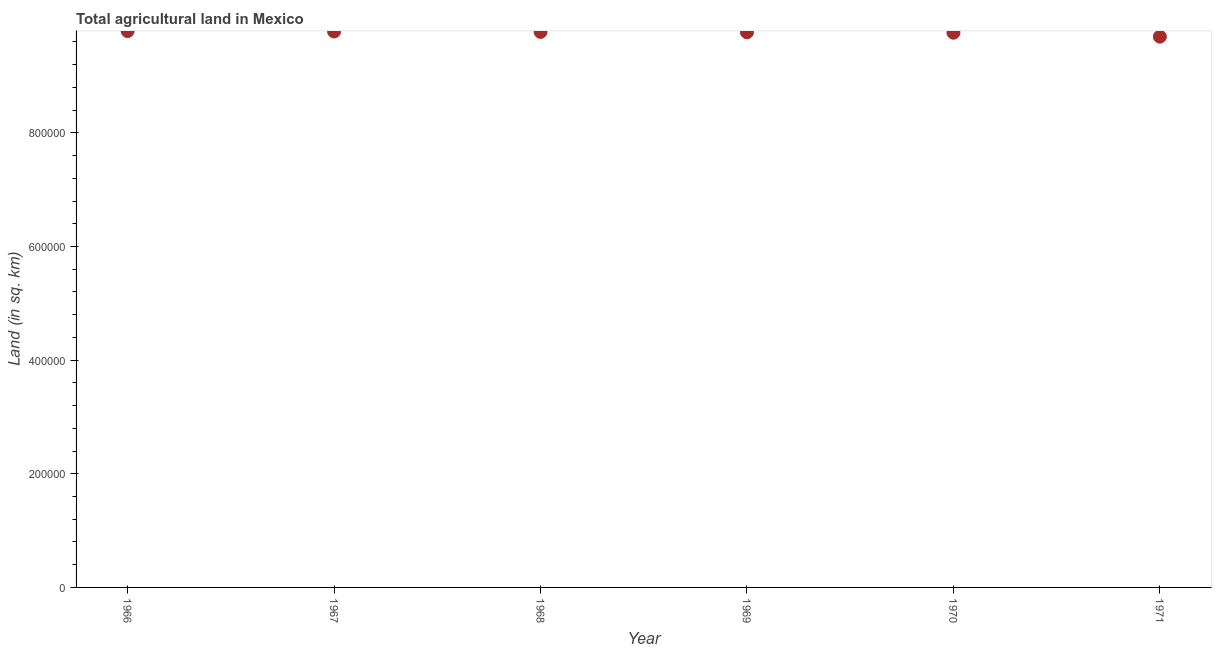What is the agricultural land in 1967?
Offer a terse response. 9.78e+05. Across all years, what is the maximum agricultural land?
Provide a short and direct response. 9.79e+05. Across all years, what is the minimum agricultural land?
Keep it short and to the point. 9.69e+05. In which year was the agricultural land maximum?
Give a very brief answer. 1966. In which year was the agricultural land minimum?
Your response must be concise. 1971. What is the sum of the agricultural land?
Your response must be concise. 5.86e+06. What is the difference between the agricultural land in 1967 and 1968?
Ensure brevity in your answer.  700. What is the average agricultural land per year?
Offer a terse response. 9.76e+05. What is the median agricultural land?
Keep it short and to the point. 9.77e+05. Do a majority of the years between 1969 and 1971 (inclusive) have agricultural land greater than 240000 sq. km?
Give a very brief answer. Yes. What is the ratio of the agricultural land in 1969 to that in 1970?
Offer a terse response. 1. Is the difference between the agricultural land in 1967 and 1969 greater than the difference between any two years?
Your response must be concise. No. What is the difference between the highest and the second highest agricultural land?
Ensure brevity in your answer.  750. Is the sum of the agricultural land in 1966 and 1970 greater than the maximum agricultural land across all years?
Provide a short and direct response. Yes. What is the difference between the highest and the lowest agricultural land?
Offer a very short reply. 9760. In how many years, is the agricultural land greater than the average agricultural land taken over all years?
Provide a succinct answer. 5. Does the agricultural land monotonically increase over the years?
Make the answer very short. No. How many dotlines are there?
Keep it short and to the point. 1. What is the title of the graph?
Your response must be concise. Total agricultural land in Mexico. What is the label or title of the X-axis?
Your answer should be compact. Year. What is the label or title of the Y-axis?
Provide a succinct answer. Land (in sq. km). What is the Land (in sq. km) in 1966?
Your response must be concise. 9.79e+05. What is the Land (in sq. km) in 1967?
Provide a short and direct response. 9.78e+05. What is the Land (in sq. km) in 1968?
Offer a terse response. 9.78e+05. What is the Land (in sq. km) in 1969?
Provide a succinct answer. 9.77e+05. What is the Land (in sq. km) in 1970?
Offer a very short reply. 9.76e+05. What is the Land (in sq. km) in 1971?
Offer a terse response. 9.69e+05. What is the difference between the Land (in sq. km) in 1966 and 1967?
Provide a short and direct response. 750. What is the difference between the Land (in sq. km) in 1966 and 1968?
Provide a short and direct response. 1450. What is the difference between the Land (in sq. km) in 1966 and 1969?
Offer a very short reply. 2050. What is the difference between the Land (in sq. km) in 1966 and 1970?
Offer a terse response. 2790. What is the difference between the Land (in sq. km) in 1966 and 1971?
Provide a succinct answer. 9760. What is the difference between the Land (in sq. km) in 1967 and 1968?
Your response must be concise. 700. What is the difference between the Land (in sq. km) in 1967 and 1969?
Ensure brevity in your answer.  1300. What is the difference between the Land (in sq. km) in 1967 and 1970?
Ensure brevity in your answer.  2040. What is the difference between the Land (in sq. km) in 1967 and 1971?
Make the answer very short. 9010. What is the difference between the Land (in sq. km) in 1968 and 1969?
Provide a succinct answer. 600. What is the difference between the Land (in sq. km) in 1968 and 1970?
Your answer should be very brief. 1340. What is the difference between the Land (in sq. km) in 1968 and 1971?
Offer a very short reply. 8310. What is the difference between the Land (in sq. km) in 1969 and 1970?
Provide a succinct answer. 740. What is the difference between the Land (in sq. km) in 1969 and 1971?
Make the answer very short. 7710. What is the difference between the Land (in sq. km) in 1970 and 1971?
Provide a short and direct response. 6970. What is the ratio of the Land (in sq. km) in 1966 to that in 1969?
Offer a very short reply. 1. What is the ratio of the Land (in sq. km) in 1966 to that in 1971?
Offer a very short reply. 1.01. What is the ratio of the Land (in sq. km) in 1968 to that in 1970?
Your answer should be very brief. 1. What is the ratio of the Land (in sq. km) in 1968 to that in 1971?
Make the answer very short. 1.01. What is the ratio of the Land (in sq. km) in 1969 to that in 1970?
Your response must be concise. 1. What is the ratio of the Land (in sq. km) in 1969 to that in 1971?
Keep it short and to the point. 1.01. 